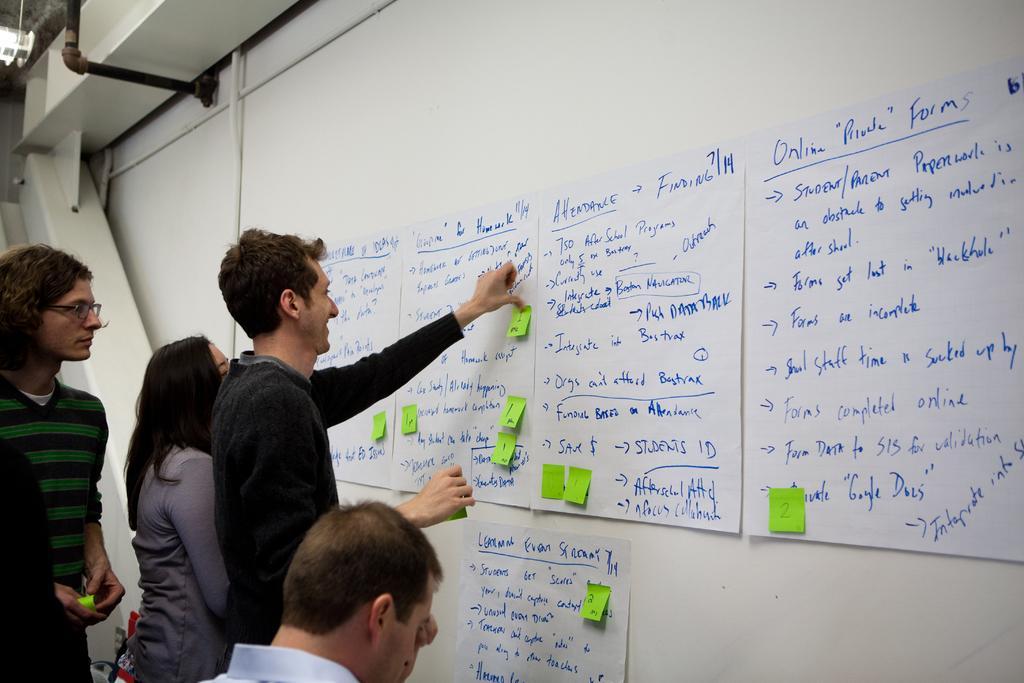How would you summarize this image in a sentence or two? In this image there are a few people standing. In front of them there is a wall. There are charts and papers sticked on the wall. There is text on the charts. In the top left there are pipes and a light to the ceiling. 